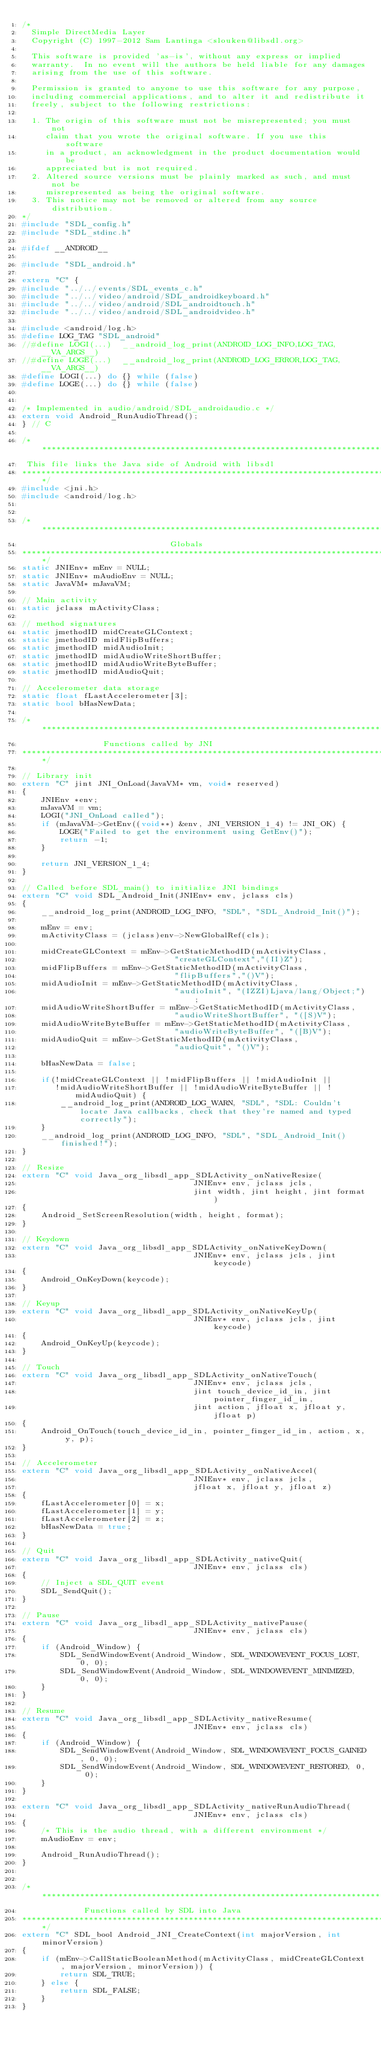<code> <loc_0><loc_0><loc_500><loc_500><_C++_>/*
  Simple DirectMedia Layer
  Copyright (C) 1997-2012 Sam Lantinga <slouken@libsdl.org>

  This software is provided 'as-is', without any express or implied
  warranty.  In no event will the authors be held liable for any damages
  arising from the use of this software.

  Permission is granted to anyone to use this software for any purpose,
  including commercial applications, and to alter it and redistribute it
  freely, subject to the following restrictions:

  1. The origin of this software must not be misrepresented; you must not
     claim that you wrote the original software. If you use this software
     in a product, an acknowledgment in the product documentation would be
     appreciated but is not required.
  2. Altered source versions must be plainly marked as such, and must not be
     misrepresented as being the original software.
  3. This notice may not be removed or altered from any source distribution.
*/
#include "SDL_config.h"
#include "SDL_stdinc.h"

#ifdef __ANDROID__

#include "SDL_android.h"

extern "C" {
#include "../../events/SDL_events_c.h"
#include "../../video/android/SDL_androidkeyboard.h"
#include "../../video/android/SDL_androidtouch.h"
#include "../../video/android/SDL_androidvideo.h"

#include <android/log.h>
#define LOG_TAG "SDL_android"
//#define LOGI(...)  __android_log_print(ANDROID_LOG_INFO,LOG_TAG,__VA_ARGS__)
//#define LOGE(...)  __android_log_print(ANDROID_LOG_ERROR,LOG_TAG,__VA_ARGS__)
#define LOGI(...) do {} while (false)
#define LOGE(...) do {} while (false)


/* Implemented in audio/android/SDL_androidaudio.c */
extern void Android_RunAudioThread();
} // C

/*******************************************************************************
 This file links the Java side of Android with libsdl
*******************************************************************************/
#include <jni.h>
#include <android/log.h>


/*******************************************************************************
                               Globals
*******************************************************************************/
static JNIEnv* mEnv = NULL;
static JNIEnv* mAudioEnv = NULL;
static JavaVM* mJavaVM;

// Main activity
static jclass mActivityClass;

// method signatures
static jmethodID midCreateGLContext;
static jmethodID midFlipBuffers;
static jmethodID midAudioInit;
static jmethodID midAudioWriteShortBuffer;
static jmethodID midAudioWriteByteBuffer;
static jmethodID midAudioQuit;

// Accelerometer data storage
static float fLastAccelerometer[3];
static bool bHasNewData;

/*******************************************************************************
                 Functions called by JNI
*******************************************************************************/

// Library init
extern "C" jint JNI_OnLoad(JavaVM* vm, void* reserved)
{
    JNIEnv *env;
    mJavaVM = vm;
    LOGI("JNI_OnLoad called");
    if (mJavaVM->GetEnv((void**) &env, JNI_VERSION_1_4) != JNI_OK) {
        LOGE("Failed to get the environment using GetEnv()");
        return -1;
    }

    return JNI_VERSION_1_4;
}

// Called before SDL_main() to initialize JNI bindings
extern "C" void SDL_Android_Init(JNIEnv* env, jclass cls)
{
    __android_log_print(ANDROID_LOG_INFO, "SDL", "SDL_Android_Init()");

    mEnv = env;
    mActivityClass = (jclass)env->NewGlobalRef(cls);

    midCreateGLContext = mEnv->GetStaticMethodID(mActivityClass,
                                "createGLContext","(II)Z");
    midFlipBuffers = mEnv->GetStaticMethodID(mActivityClass,
                                "flipBuffers","()V");
    midAudioInit = mEnv->GetStaticMethodID(mActivityClass, 
                                "audioInit", "(IZZI)Ljava/lang/Object;");
    midAudioWriteShortBuffer = mEnv->GetStaticMethodID(mActivityClass,
                                "audioWriteShortBuffer", "([S)V");
    midAudioWriteByteBuffer = mEnv->GetStaticMethodID(mActivityClass,
                                "audioWriteByteBuffer", "([B)V");
    midAudioQuit = mEnv->GetStaticMethodID(mActivityClass,
                                "audioQuit", "()V");

    bHasNewData = false;

    if(!midCreateGLContext || !midFlipBuffers || !midAudioInit ||
       !midAudioWriteShortBuffer || !midAudioWriteByteBuffer || !midAudioQuit) {
        __android_log_print(ANDROID_LOG_WARN, "SDL", "SDL: Couldn't locate Java callbacks, check that they're named and typed correctly");
    }
    __android_log_print(ANDROID_LOG_INFO, "SDL", "SDL_Android_Init() finished!");
}

// Resize
extern "C" void Java_org_libsdl_app_SDLActivity_onNativeResize(
                                    JNIEnv* env, jclass jcls,
                                    jint width, jint height, jint format)
{
    Android_SetScreenResolution(width, height, format);
}

// Keydown
extern "C" void Java_org_libsdl_app_SDLActivity_onNativeKeyDown(
                                    JNIEnv* env, jclass jcls, jint keycode)
{
    Android_OnKeyDown(keycode);
}

// Keyup
extern "C" void Java_org_libsdl_app_SDLActivity_onNativeKeyUp(
                                    JNIEnv* env, jclass jcls, jint keycode)
{
    Android_OnKeyUp(keycode);
}

// Touch
extern "C" void Java_org_libsdl_app_SDLActivity_onNativeTouch(
                                    JNIEnv* env, jclass jcls,
                                    jint touch_device_id_in, jint pointer_finger_id_in,
                                    jint action, jfloat x, jfloat y, jfloat p)
{
    Android_OnTouch(touch_device_id_in, pointer_finger_id_in, action, x, y, p);
}

// Accelerometer
extern "C" void Java_org_libsdl_app_SDLActivity_onNativeAccel(
                                    JNIEnv* env, jclass jcls,
                                    jfloat x, jfloat y, jfloat z)
{
    fLastAccelerometer[0] = x;
    fLastAccelerometer[1] = y;
    fLastAccelerometer[2] = z;
    bHasNewData = true;
}

// Quit
extern "C" void Java_org_libsdl_app_SDLActivity_nativeQuit(
                                    JNIEnv* env, jclass cls)
{    
    // Inject a SDL_QUIT event
    SDL_SendQuit();
}

// Pause
extern "C" void Java_org_libsdl_app_SDLActivity_nativePause(
                                    JNIEnv* env, jclass cls)
{
    if (Android_Window) {
        SDL_SendWindowEvent(Android_Window, SDL_WINDOWEVENT_FOCUS_LOST, 0, 0);
        SDL_SendWindowEvent(Android_Window, SDL_WINDOWEVENT_MINIMIZED, 0, 0);
    }
}

// Resume
extern "C" void Java_org_libsdl_app_SDLActivity_nativeResume(
                                    JNIEnv* env, jclass cls)
{
    if (Android_Window) {
        SDL_SendWindowEvent(Android_Window, SDL_WINDOWEVENT_FOCUS_GAINED, 0, 0);
        SDL_SendWindowEvent(Android_Window, SDL_WINDOWEVENT_RESTORED, 0, 0);
    }
}

extern "C" void Java_org_libsdl_app_SDLActivity_nativeRunAudioThread(
                                    JNIEnv* env, jclass cls)
{
    /* This is the audio thread, with a different environment */
    mAudioEnv = env;

    Android_RunAudioThread();
}


/*******************************************************************************
             Functions called by SDL into Java
*******************************************************************************/
extern "C" SDL_bool Android_JNI_CreateContext(int majorVersion, int minorVersion)
{
    if (mEnv->CallStaticBooleanMethod(mActivityClass, midCreateGLContext, majorVersion, minorVersion)) {
        return SDL_TRUE;
    } else {
        return SDL_FALSE;
    }
}
</code> 